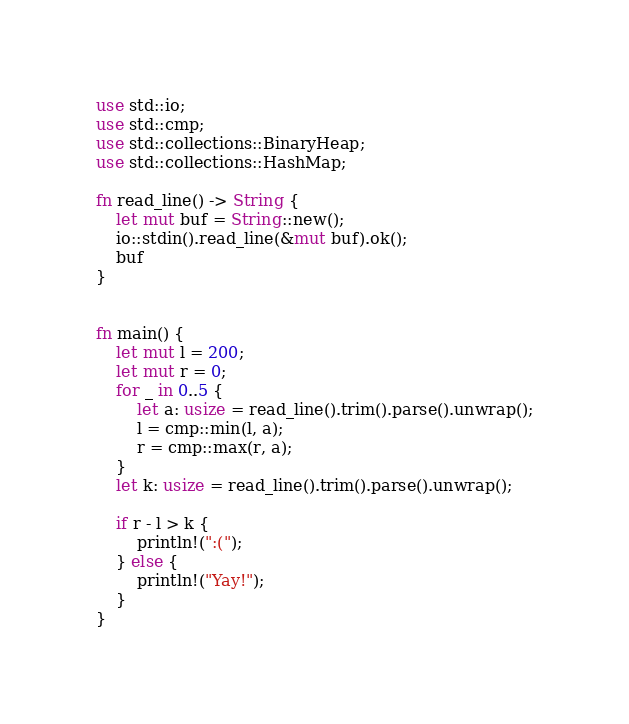Convert code to text. <code><loc_0><loc_0><loc_500><loc_500><_Rust_>use std::io;
use std::cmp;
use std::collections::BinaryHeap;
use std::collections::HashMap;

fn read_line() -> String {
    let mut buf = String::new();
    io::stdin().read_line(&mut buf).ok();
    buf
}


fn main() {
    let mut l = 200;
    let mut r = 0;
    for _ in 0..5 {
        let a: usize = read_line().trim().parse().unwrap();
        l = cmp::min(l, a);
        r = cmp::max(r, a);
    }
    let k: usize = read_line().trim().parse().unwrap();

    if r - l > k {
        println!(":(");
    } else {
        println!("Yay!");
    }
}
</code> 